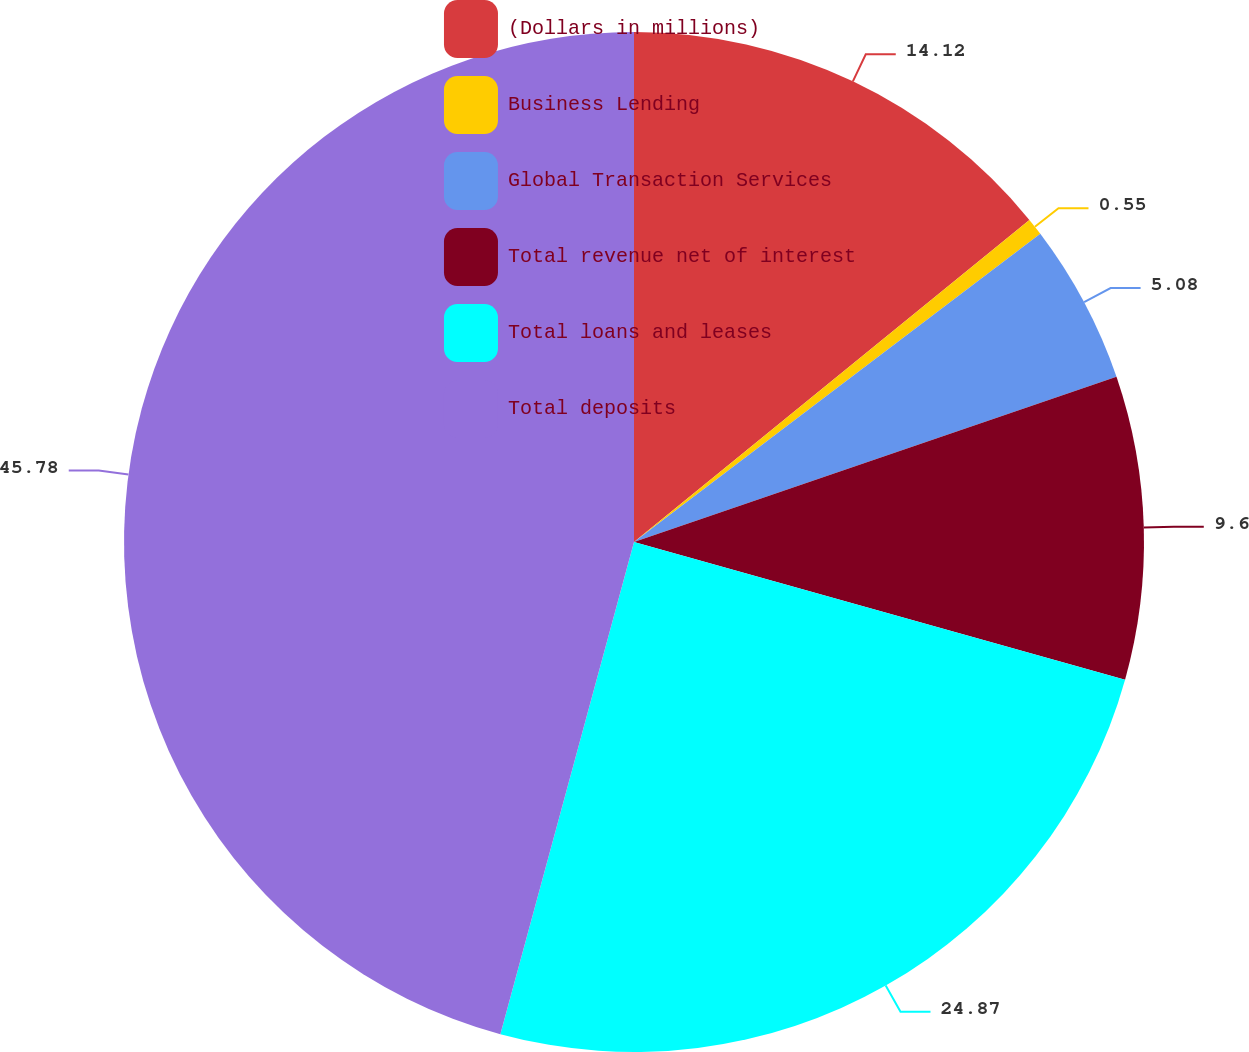Convert chart. <chart><loc_0><loc_0><loc_500><loc_500><pie_chart><fcel>(Dollars in millions)<fcel>Business Lending<fcel>Global Transaction Services<fcel>Total revenue net of interest<fcel>Total loans and leases<fcel>Total deposits<nl><fcel>14.12%<fcel>0.55%<fcel>5.08%<fcel>9.6%<fcel>24.87%<fcel>45.78%<nl></chart> 